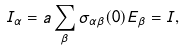<formula> <loc_0><loc_0><loc_500><loc_500>I _ { \alpha } = a \sum _ { \beta } \sigma _ { \alpha \beta } ( 0 ) E _ { \beta } = I ,</formula> 